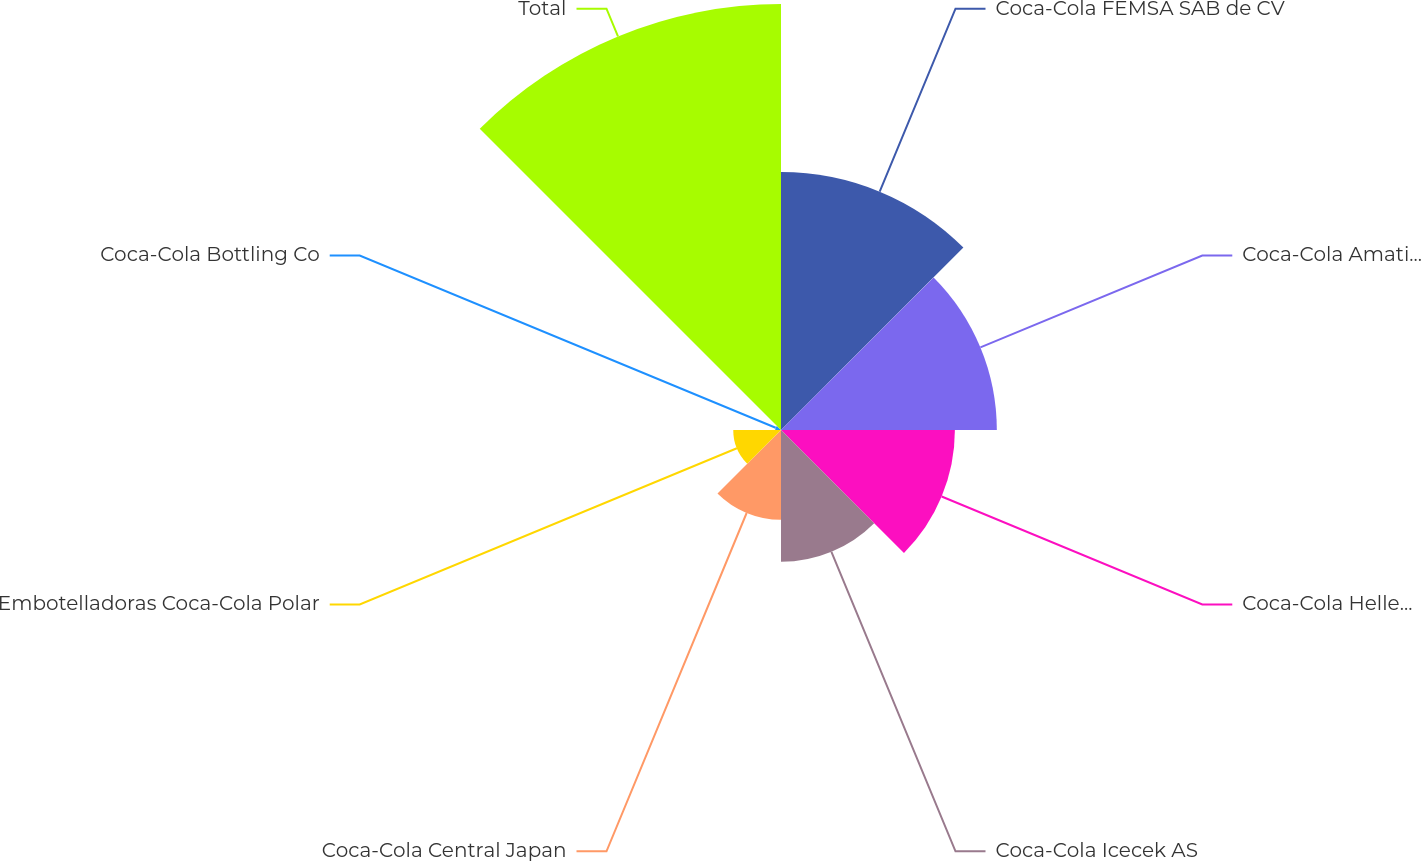Convert chart to OTSL. <chart><loc_0><loc_0><loc_500><loc_500><pie_chart><fcel>Coca-Cola FEMSA SAB de CV<fcel>Coca-Cola Amatil Limited<fcel>Coca-Cola Hellenic Bottling<fcel>Coca-Cola Icecek AS<fcel>Coca-Cola Central Japan<fcel>Embotelladoras Coca-Cola Polar<fcel>Coca-Cola Bottling Co<fcel>Total<nl><fcel>19.12%<fcel>16.0%<fcel>12.89%<fcel>9.77%<fcel>6.66%<fcel>3.54%<fcel>0.43%<fcel>31.58%<nl></chart> 